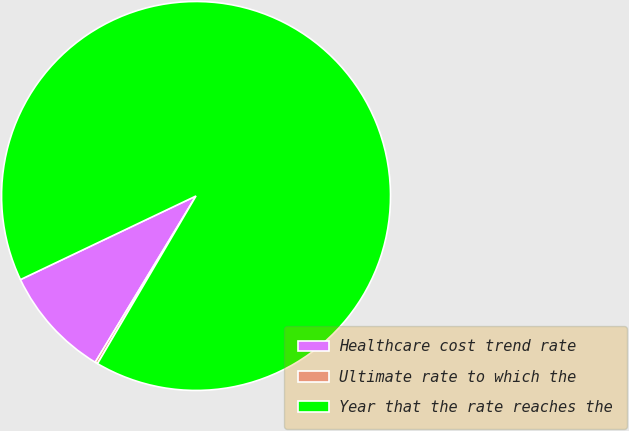Convert chart. <chart><loc_0><loc_0><loc_500><loc_500><pie_chart><fcel>Healthcare cost trend rate<fcel>Ultimate rate to which the<fcel>Year that the rate reaches the<nl><fcel>9.25%<fcel>0.22%<fcel>90.52%<nl></chart> 